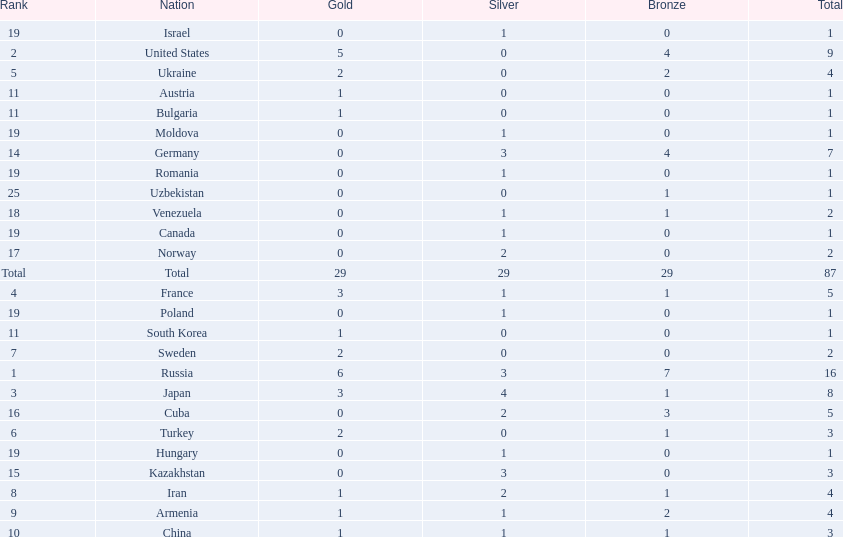Which nations participated in the championships? Russia, United States, Japan, France, Ukraine, Turkey, Sweden, Iran, Armenia, China, Austria, Bulgaria, South Korea, Germany, Kazakhstan, Cuba, Norway, Venezuela, Canada, Hungary, Israel, Moldova, Poland, Romania, Uzbekistan. How many bronze medals did they receive? 7, 4, 1, 1, 2, 1, 0, 1, 2, 1, 0, 0, 0, 4, 0, 3, 0, 1, 0, 0, 0, 0, 0, 0, 1, 29. How many in total? 16, 9, 8, 5, 4, 3, 2, 4, 4, 3, 1, 1, 1, 7, 3, 5, 2, 2, 1, 1, 1, 1, 1, 1, 1. And which team won only one medal -- the bronze? Uzbekistan. 